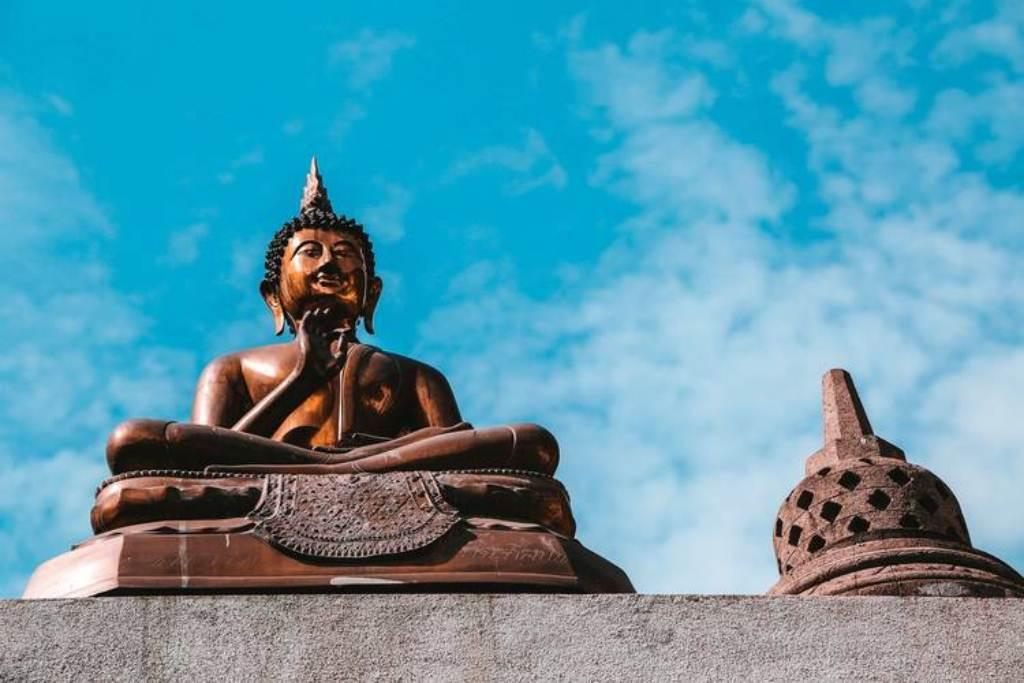What is the main subject in the image? There is a statue in the image. What can be seen in the background of the image? There are clouds visible in the sky in the background of the image. What type of holiday is being celebrated in the image? There is no indication of a holiday being celebrated in the image, as it only features a statue and clouds in the sky. Can you hear the drum being played in the image? There is no drum present in the image, so it cannot be heard or seen. 